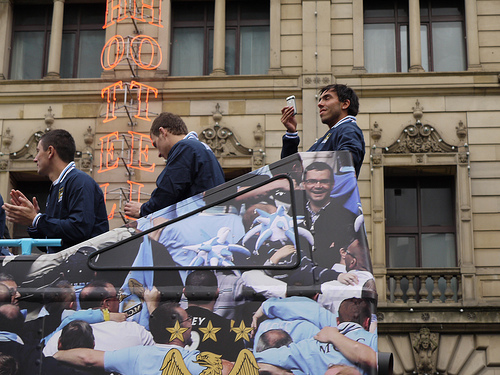<image>
Can you confirm if the building is in front of the man? Yes. The building is positioned in front of the man, appearing closer to the camera viewpoint. 